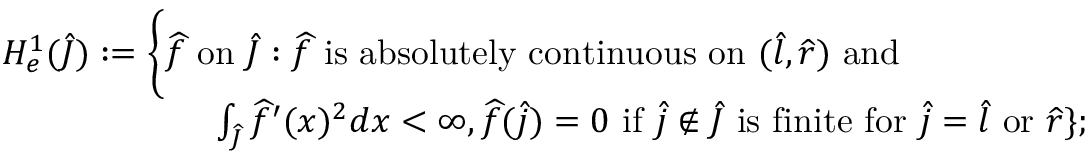<formula> <loc_0><loc_0><loc_500><loc_500>\begin{array} { r l } & { H _ { e } ^ { 1 } ( \widehat { J } ) \colon = \Big \{ \widehat { f } o n \widehat { J } \colon \widehat { f } i s a b s o l u t e l y c o n t i n u o u s o n ( \widehat { l } , \widehat { r } ) a n d } \\ & { \quad \int _ { \widehat { J } } \widehat { f } ^ { \prime } ( x ) ^ { 2 } d x < \infty , \widehat { f } ( \widehat { j } ) = 0 i f \widehat { j } \notin \widehat { J } i s f i n i t e f o r \widehat { j } = \widehat { l } o r \widehat { r } \} ; } \end{array}</formula> 